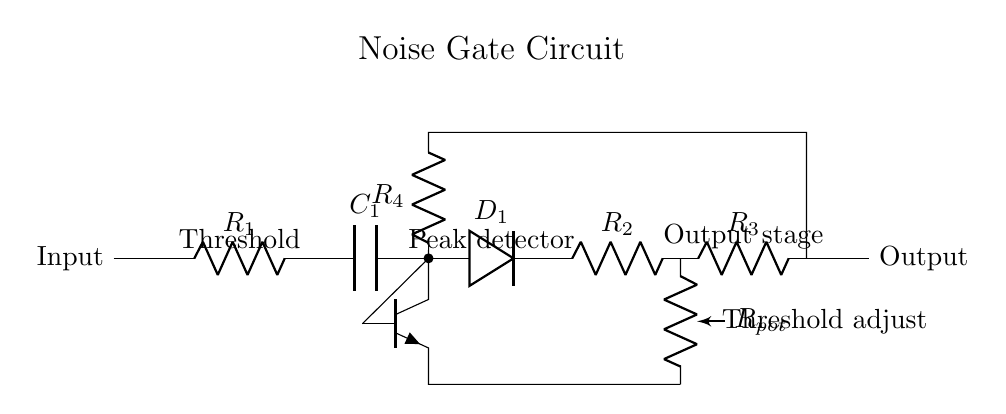What is the input component? The input component of the circuit is represented by the initial node labeled "Input." It connects to the first resistor, indicating where the audio signal enters the circuit.
Answer: Input What purpose does the capacitor serve in this circuit? The capacitor, labeled C1, is used to smooth the signal and block any DC component, allowing only the AC audio signals to pass through to the next stages.
Answer: Smoothing What is the value of the potentiometer represented in the circuit? The potentiometer is labeled Rpot, indicating that it is variable and used for adjusting the threshold of the noise gate. The exact value is not specified, only its function is indicated.
Answer: Rpot How many resistors are present in this circuit? By examining the diagram, there are four resistors labeled R1, R2, R3, and R4. All are necessary for regulating current at different stages of the circuit.
Answer: Four What does the transistor in the circuit do? The transistor, represented as Q1, acts as a switch or amplifier that controls whether the output stage passes the audio signal or mutes it based on the detection of signal levels.
Answer: Switch or amplifier What stage follows the peak detector in this circuit? The output stage follows the peak detector, as indicated by the labeling in the diagram. It is the final stage that processes the audio signal before outputting it.
Answer: Output stage What does the threshold adjust control? The threshold adjust, indicated by the potentiometer labeled Rpot, allows the user to set the level at which the noise gate activates, enabling control over unwanted background noise.
Answer: Noise gate activation 